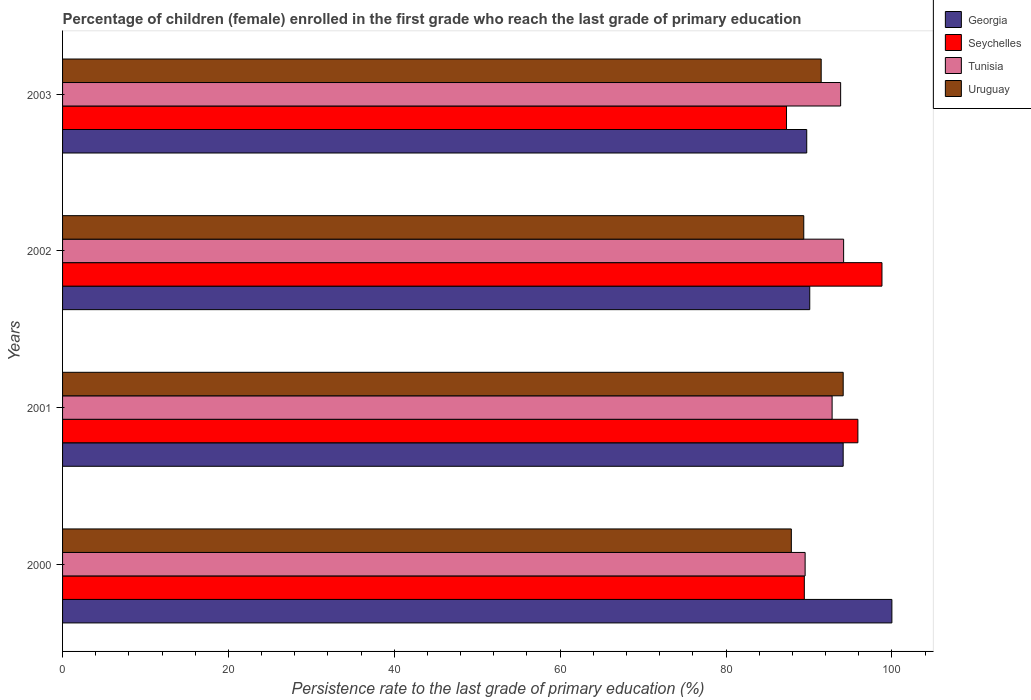Are the number of bars on each tick of the Y-axis equal?
Ensure brevity in your answer.  Yes. How many bars are there on the 3rd tick from the top?
Offer a terse response. 4. What is the persistence rate of children in Uruguay in 2003?
Your response must be concise. 91.48. Across all years, what is the minimum persistence rate of children in Seychelles?
Your answer should be very brief. 87.3. In which year was the persistence rate of children in Georgia maximum?
Provide a short and direct response. 2000. In which year was the persistence rate of children in Georgia minimum?
Your answer should be compact. 2003. What is the total persistence rate of children in Tunisia in the graph?
Your answer should be compact. 370.33. What is the difference between the persistence rate of children in Georgia in 2000 and that in 2001?
Provide a succinct answer. 5.87. What is the difference between the persistence rate of children in Georgia in 2003 and the persistence rate of children in Tunisia in 2002?
Provide a succinct answer. -4.45. What is the average persistence rate of children in Tunisia per year?
Your answer should be compact. 92.58. In the year 2003, what is the difference between the persistence rate of children in Seychelles and persistence rate of children in Georgia?
Ensure brevity in your answer.  -2.44. What is the ratio of the persistence rate of children in Tunisia in 2001 to that in 2003?
Your answer should be very brief. 0.99. Is the difference between the persistence rate of children in Seychelles in 2000 and 2001 greater than the difference between the persistence rate of children in Georgia in 2000 and 2001?
Your answer should be compact. No. What is the difference between the highest and the second highest persistence rate of children in Seychelles?
Keep it short and to the point. 2.9. What is the difference between the highest and the lowest persistence rate of children in Georgia?
Provide a short and direct response. 10.27. Is it the case that in every year, the sum of the persistence rate of children in Tunisia and persistence rate of children in Uruguay is greater than the sum of persistence rate of children in Georgia and persistence rate of children in Seychelles?
Make the answer very short. No. What does the 2nd bar from the top in 2003 represents?
Your response must be concise. Tunisia. What does the 1st bar from the bottom in 2001 represents?
Make the answer very short. Georgia. Is it the case that in every year, the sum of the persistence rate of children in Tunisia and persistence rate of children in Seychelles is greater than the persistence rate of children in Georgia?
Your response must be concise. Yes. Are all the bars in the graph horizontal?
Your answer should be very brief. Yes. How many years are there in the graph?
Your response must be concise. 4. Does the graph contain grids?
Offer a very short reply. No. Where does the legend appear in the graph?
Your response must be concise. Top right. What is the title of the graph?
Keep it short and to the point. Percentage of children (female) enrolled in the first grade who reach the last grade of primary education. Does "North America" appear as one of the legend labels in the graph?
Your answer should be compact. No. What is the label or title of the X-axis?
Offer a very short reply. Persistence rate to the last grade of primary education (%). What is the Persistence rate to the last grade of primary education (%) of Georgia in 2000?
Offer a terse response. 100. What is the Persistence rate to the last grade of primary education (%) of Seychelles in 2000?
Provide a succinct answer. 89.44. What is the Persistence rate to the last grade of primary education (%) in Tunisia in 2000?
Ensure brevity in your answer.  89.54. What is the Persistence rate to the last grade of primary education (%) of Uruguay in 2000?
Offer a very short reply. 87.88. What is the Persistence rate to the last grade of primary education (%) of Georgia in 2001?
Ensure brevity in your answer.  94.13. What is the Persistence rate to the last grade of primary education (%) of Seychelles in 2001?
Keep it short and to the point. 95.9. What is the Persistence rate to the last grade of primary education (%) of Tunisia in 2001?
Your answer should be compact. 92.79. What is the Persistence rate to the last grade of primary education (%) in Uruguay in 2001?
Provide a succinct answer. 94.13. What is the Persistence rate to the last grade of primary education (%) of Georgia in 2002?
Offer a terse response. 90.1. What is the Persistence rate to the last grade of primary education (%) of Seychelles in 2002?
Your answer should be very brief. 98.8. What is the Persistence rate to the last grade of primary education (%) in Tunisia in 2002?
Provide a succinct answer. 94.18. What is the Persistence rate to the last grade of primary education (%) of Uruguay in 2002?
Your answer should be compact. 89.37. What is the Persistence rate to the last grade of primary education (%) of Georgia in 2003?
Provide a succinct answer. 89.73. What is the Persistence rate to the last grade of primary education (%) of Seychelles in 2003?
Ensure brevity in your answer.  87.3. What is the Persistence rate to the last grade of primary education (%) of Tunisia in 2003?
Your answer should be very brief. 93.82. What is the Persistence rate to the last grade of primary education (%) in Uruguay in 2003?
Make the answer very short. 91.48. Across all years, what is the maximum Persistence rate to the last grade of primary education (%) in Georgia?
Make the answer very short. 100. Across all years, what is the maximum Persistence rate to the last grade of primary education (%) in Seychelles?
Make the answer very short. 98.8. Across all years, what is the maximum Persistence rate to the last grade of primary education (%) in Tunisia?
Ensure brevity in your answer.  94.18. Across all years, what is the maximum Persistence rate to the last grade of primary education (%) in Uruguay?
Your answer should be compact. 94.13. Across all years, what is the minimum Persistence rate to the last grade of primary education (%) in Georgia?
Your answer should be very brief. 89.73. Across all years, what is the minimum Persistence rate to the last grade of primary education (%) of Seychelles?
Make the answer very short. 87.3. Across all years, what is the minimum Persistence rate to the last grade of primary education (%) in Tunisia?
Offer a terse response. 89.54. Across all years, what is the minimum Persistence rate to the last grade of primary education (%) of Uruguay?
Ensure brevity in your answer.  87.88. What is the total Persistence rate to the last grade of primary education (%) in Georgia in the graph?
Provide a succinct answer. 373.95. What is the total Persistence rate to the last grade of primary education (%) in Seychelles in the graph?
Your answer should be compact. 371.44. What is the total Persistence rate to the last grade of primary education (%) in Tunisia in the graph?
Keep it short and to the point. 370.33. What is the total Persistence rate to the last grade of primary education (%) in Uruguay in the graph?
Your answer should be compact. 362.85. What is the difference between the Persistence rate to the last grade of primary education (%) of Georgia in 2000 and that in 2001?
Ensure brevity in your answer.  5.87. What is the difference between the Persistence rate to the last grade of primary education (%) in Seychelles in 2000 and that in 2001?
Give a very brief answer. -6.46. What is the difference between the Persistence rate to the last grade of primary education (%) of Tunisia in 2000 and that in 2001?
Provide a succinct answer. -3.25. What is the difference between the Persistence rate to the last grade of primary education (%) in Uruguay in 2000 and that in 2001?
Provide a succinct answer. -6.25. What is the difference between the Persistence rate to the last grade of primary education (%) in Georgia in 2000 and that in 2002?
Keep it short and to the point. 9.9. What is the difference between the Persistence rate to the last grade of primary education (%) of Seychelles in 2000 and that in 2002?
Offer a terse response. -9.36. What is the difference between the Persistence rate to the last grade of primary education (%) of Tunisia in 2000 and that in 2002?
Provide a succinct answer. -4.64. What is the difference between the Persistence rate to the last grade of primary education (%) of Uruguay in 2000 and that in 2002?
Make the answer very short. -1.5. What is the difference between the Persistence rate to the last grade of primary education (%) of Georgia in 2000 and that in 2003?
Offer a very short reply. 10.27. What is the difference between the Persistence rate to the last grade of primary education (%) in Seychelles in 2000 and that in 2003?
Your answer should be compact. 2.15. What is the difference between the Persistence rate to the last grade of primary education (%) in Tunisia in 2000 and that in 2003?
Keep it short and to the point. -4.28. What is the difference between the Persistence rate to the last grade of primary education (%) of Uruguay in 2000 and that in 2003?
Offer a very short reply. -3.6. What is the difference between the Persistence rate to the last grade of primary education (%) in Georgia in 2001 and that in 2002?
Offer a very short reply. 4.03. What is the difference between the Persistence rate to the last grade of primary education (%) of Seychelles in 2001 and that in 2002?
Provide a succinct answer. -2.9. What is the difference between the Persistence rate to the last grade of primary education (%) in Tunisia in 2001 and that in 2002?
Provide a succinct answer. -1.39. What is the difference between the Persistence rate to the last grade of primary education (%) of Uruguay in 2001 and that in 2002?
Give a very brief answer. 4.76. What is the difference between the Persistence rate to the last grade of primary education (%) in Georgia in 2001 and that in 2003?
Keep it short and to the point. 4.39. What is the difference between the Persistence rate to the last grade of primary education (%) in Seychelles in 2001 and that in 2003?
Keep it short and to the point. 8.61. What is the difference between the Persistence rate to the last grade of primary education (%) in Tunisia in 2001 and that in 2003?
Ensure brevity in your answer.  -1.03. What is the difference between the Persistence rate to the last grade of primary education (%) of Uruguay in 2001 and that in 2003?
Make the answer very short. 2.65. What is the difference between the Persistence rate to the last grade of primary education (%) in Georgia in 2002 and that in 2003?
Make the answer very short. 0.36. What is the difference between the Persistence rate to the last grade of primary education (%) of Seychelles in 2002 and that in 2003?
Your answer should be very brief. 11.51. What is the difference between the Persistence rate to the last grade of primary education (%) in Tunisia in 2002 and that in 2003?
Your answer should be compact. 0.36. What is the difference between the Persistence rate to the last grade of primary education (%) of Uruguay in 2002 and that in 2003?
Ensure brevity in your answer.  -2.1. What is the difference between the Persistence rate to the last grade of primary education (%) in Georgia in 2000 and the Persistence rate to the last grade of primary education (%) in Seychelles in 2001?
Keep it short and to the point. 4.1. What is the difference between the Persistence rate to the last grade of primary education (%) in Georgia in 2000 and the Persistence rate to the last grade of primary education (%) in Tunisia in 2001?
Your answer should be compact. 7.21. What is the difference between the Persistence rate to the last grade of primary education (%) of Georgia in 2000 and the Persistence rate to the last grade of primary education (%) of Uruguay in 2001?
Provide a short and direct response. 5.87. What is the difference between the Persistence rate to the last grade of primary education (%) of Seychelles in 2000 and the Persistence rate to the last grade of primary education (%) of Tunisia in 2001?
Provide a short and direct response. -3.35. What is the difference between the Persistence rate to the last grade of primary education (%) of Seychelles in 2000 and the Persistence rate to the last grade of primary education (%) of Uruguay in 2001?
Your answer should be compact. -4.69. What is the difference between the Persistence rate to the last grade of primary education (%) in Tunisia in 2000 and the Persistence rate to the last grade of primary education (%) in Uruguay in 2001?
Give a very brief answer. -4.59. What is the difference between the Persistence rate to the last grade of primary education (%) of Georgia in 2000 and the Persistence rate to the last grade of primary education (%) of Seychelles in 2002?
Offer a terse response. 1.2. What is the difference between the Persistence rate to the last grade of primary education (%) in Georgia in 2000 and the Persistence rate to the last grade of primary education (%) in Tunisia in 2002?
Your answer should be compact. 5.82. What is the difference between the Persistence rate to the last grade of primary education (%) of Georgia in 2000 and the Persistence rate to the last grade of primary education (%) of Uruguay in 2002?
Your response must be concise. 10.63. What is the difference between the Persistence rate to the last grade of primary education (%) of Seychelles in 2000 and the Persistence rate to the last grade of primary education (%) of Tunisia in 2002?
Offer a very short reply. -4.74. What is the difference between the Persistence rate to the last grade of primary education (%) of Seychelles in 2000 and the Persistence rate to the last grade of primary education (%) of Uruguay in 2002?
Your answer should be compact. 0.07. What is the difference between the Persistence rate to the last grade of primary education (%) in Tunisia in 2000 and the Persistence rate to the last grade of primary education (%) in Uruguay in 2002?
Your response must be concise. 0.17. What is the difference between the Persistence rate to the last grade of primary education (%) of Georgia in 2000 and the Persistence rate to the last grade of primary education (%) of Seychelles in 2003?
Offer a terse response. 12.71. What is the difference between the Persistence rate to the last grade of primary education (%) of Georgia in 2000 and the Persistence rate to the last grade of primary education (%) of Tunisia in 2003?
Make the answer very short. 6.18. What is the difference between the Persistence rate to the last grade of primary education (%) in Georgia in 2000 and the Persistence rate to the last grade of primary education (%) in Uruguay in 2003?
Your answer should be very brief. 8.52. What is the difference between the Persistence rate to the last grade of primary education (%) of Seychelles in 2000 and the Persistence rate to the last grade of primary education (%) of Tunisia in 2003?
Make the answer very short. -4.38. What is the difference between the Persistence rate to the last grade of primary education (%) in Seychelles in 2000 and the Persistence rate to the last grade of primary education (%) in Uruguay in 2003?
Make the answer very short. -2.03. What is the difference between the Persistence rate to the last grade of primary education (%) in Tunisia in 2000 and the Persistence rate to the last grade of primary education (%) in Uruguay in 2003?
Provide a short and direct response. -1.94. What is the difference between the Persistence rate to the last grade of primary education (%) in Georgia in 2001 and the Persistence rate to the last grade of primary education (%) in Seychelles in 2002?
Give a very brief answer. -4.68. What is the difference between the Persistence rate to the last grade of primary education (%) in Georgia in 2001 and the Persistence rate to the last grade of primary education (%) in Tunisia in 2002?
Your response must be concise. -0.05. What is the difference between the Persistence rate to the last grade of primary education (%) of Georgia in 2001 and the Persistence rate to the last grade of primary education (%) of Uruguay in 2002?
Give a very brief answer. 4.75. What is the difference between the Persistence rate to the last grade of primary education (%) in Seychelles in 2001 and the Persistence rate to the last grade of primary education (%) in Tunisia in 2002?
Your answer should be very brief. 1.72. What is the difference between the Persistence rate to the last grade of primary education (%) in Seychelles in 2001 and the Persistence rate to the last grade of primary education (%) in Uruguay in 2002?
Provide a short and direct response. 6.53. What is the difference between the Persistence rate to the last grade of primary education (%) of Tunisia in 2001 and the Persistence rate to the last grade of primary education (%) of Uruguay in 2002?
Offer a terse response. 3.42. What is the difference between the Persistence rate to the last grade of primary education (%) in Georgia in 2001 and the Persistence rate to the last grade of primary education (%) in Seychelles in 2003?
Keep it short and to the point. 6.83. What is the difference between the Persistence rate to the last grade of primary education (%) in Georgia in 2001 and the Persistence rate to the last grade of primary education (%) in Tunisia in 2003?
Provide a short and direct response. 0.31. What is the difference between the Persistence rate to the last grade of primary education (%) in Georgia in 2001 and the Persistence rate to the last grade of primary education (%) in Uruguay in 2003?
Make the answer very short. 2.65. What is the difference between the Persistence rate to the last grade of primary education (%) of Seychelles in 2001 and the Persistence rate to the last grade of primary education (%) of Tunisia in 2003?
Offer a very short reply. 2.08. What is the difference between the Persistence rate to the last grade of primary education (%) in Seychelles in 2001 and the Persistence rate to the last grade of primary education (%) in Uruguay in 2003?
Ensure brevity in your answer.  4.43. What is the difference between the Persistence rate to the last grade of primary education (%) in Tunisia in 2001 and the Persistence rate to the last grade of primary education (%) in Uruguay in 2003?
Provide a succinct answer. 1.32. What is the difference between the Persistence rate to the last grade of primary education (%) in Georgia in 2002 and the Persistence rate to the last grade of primary education (%) in Seychelles in 2003?
Offer a very short reply. 2.8. What is the difference between the Persistence rate to the last grade of primary education (%) in Georgia in 2002 and the Persistence rate to the last grade of primary education (%) in Tunisia in 2003?
Provide a succinct answer. -3.72. What is the difference between the Persistence rate to the last grade of primary education (%) of Georgia in 2002 and the Persistence rate to the last grade of primary education (%) of Uruguay in 2003?
Your answer should be very brief. -1.38. What is the difference between the Persistence rate to the last grade of primary education (%) of Seychelles in 2002 and the Persistence rate to the last grade of primary education (%) of Tunisia in 2003?
Provide a short and direct response. 4.98. What is the difference between the Persistence rate to the last grade of primary education (%) in Seychelles in 2002 and the Persistence rate to the last grade of primary education (%) in Uruguay in 2003?
Provide a short and direct response. 7.33. What is the difference between the Persistence rate to the last grade of primary education (%) of Tunisia in 2002 and the Persistence rate to the last grade of primary education (%) of Uruguay in 2003?
Your answer should be compact. 2.71. What is the average Persistence rate to the last grade of primary education (%) in Georgia per year?
Ensure brevity in your answer.  93.49. What is the average Persistence rate to the last grade of primary education (%) of Seychelles per year?
Provide a succinct answer. 92.86. What is the average Persistence rate to the last grade of primary education (%) in Tunisia per year?
Your answer should be compact. 92.58. What is the average Persistence rate to the last grade of primary education (%) of Uruguay per year?
Provide a succinct answer. 90.71. In the year 2000, what is the difference between the Persistence rate to the last grade of primary education (%) in Georgia and Persistence rate to the last grade of primary education (%) in Seychelles?
Your answer should be compact. 10.56. In the year 2000, what is the difference between the Persistence rate to the last grade of primary education (%) in Georgia and Persistence rate to the last grade of primary education (%) in Tunisia?
Make the answer very short. 10.46. In the year 2000, what is the difference between the Persistence rate to the last grade of primary education (%) in Georgia and Persistence rate to the last grade of primary education (%) in Uruguay?
Offer a very short reply. 12.12. In the year 2000, what is the difference between the Persistence rate to the last grade of primary education (%) of Seychelles and Persistence rate to the last grade of primary education (%) of Tunisia?
Provide a succinct answer. -0.1. In the year 2000, what is the difference between the Persistence rate to the last grade of primary education (%) of Seychelles and Persistence rate to the last grade of primary education (%) of Uruguay?
Offer a very short reply. 1.57. In the year 2000, what is the difference between the Persistence rate to the last grade of primary education (%) in Tunisia and Persistence rate to the last grade of primary education (%) in Uruguay?
Offer a very short reply. 1.66. In the year 2001, what is the difference between the Persistence rate to the last grade of primary education (%) of Georgia and Persistence rate to the last grade of primary education (%) of Seychelles?
Provide a short and direct response. -1.77. In the year 2001, what is the difference between the Persistence rate to the last grade of primary education (%) in Georgia and Persistence rate to the last grade of primary education (%) in Tunisia?
Provide a succinct answer. 1.33. In the year 2001, what is the difference between the Persistence rate to the last grade of primary education (%) in Georgia and Persistence rate to the last grade of primary education (%) in Uruguay?
Offer a terse response. -0. In the year 2001, what is the difference between the Persistence rate to the last grade of primary education (%) in Seychelles and Persistence rate to the last grade of primary education (%) in Tunisia?
Provide a succinct answer. 3.11. In the year 2001, what is the difference between the Persistence rate to the last grade of primary education (%) in Seychelles and Persistence rate to the last grade of primary education (%) in Uruguay?
Offer a very short reply. 1.77. In the year 2001, what is the difference between the Persistence rate to the last grade of primary education (%) in Tunisia and Persistence rate to the last grade of primary education (%) in Uruguay?
Keep it short and to the point. -1.34. In the year 2002, what is the difference between the Persistence rate to the last grade of primary education (%) of Georgia and Persistence rate to the last grade of primary education (%) of Seychelles?
Your answer should be very brief. -8.71. In the year 2002, what is the difference between the Persistence rate to the last grade of primary education (%) in Georgia and Persistence rate to the last grade of primary education (%) in Tunisia?
Keep it short and to the point. -4.08. In the year 2002, what is the difference between the Persistence rate to the last grade of primary education (%) in Georgia and Persistence rate to the last grade of primary education (%) in Uruguay?
Offer a very short reply. 0.72. In the year 2002, what is the difference between the Persistence rate to the last grade of primary education (%) in Seychelles and Persistence rate to the last grade of primary education (%) in Tunisia?
Provide a short and direct response. 4.62. In the year 2002, what is the difference between the Persistence rate to the last grade of primary education (%) in Seychelles and Persistence rate to the last grade of primary education (%) in Uruguay?
Give a very brief answer. 9.43. In the year 2002, what is the difference between the Persistence rate to the last grade of primary education (%) of Tunisia and Persistence rate to the last grade of primary education (%) of Uruguay?
Make the answer very short. 4.81. In the year 2003, what is the difference between the Persistence rate to the last grade of primary education (%) in Georgia and Persistence rate to the last grade of primary education (%) in Seychelles?
Provide a short and direct response. 2.44. In the year 2003, what is the difference between the Persistence rate to the last grade of primary education (%) of Georgia and Persistence rate to the last grade of primary education (%) of Tunisia?
Offer a very short reply. -4.09. In the year 2003, what is the difference between the Persistence rate to the last grade of primary education (%) of Georgia and Persistence rate to the last grade of primary education (%) of Uruguay?
Ensure brevity in your answer.  -1.74. In the year 2003, what is the difference between the Persistence rate to the last grade of primary education (%) of Seychelles and Persistence rate to the last grade of primary education (%) of Tunisia?
Give a very brief answer. -6.53. In the year 2003, what is the difference between the Persistence rate to the last grade of primary education (%) of Seychelles and Persistence rate to the last grade of primary education (%) of Uruguay?
Your answer should be very brief. -4.18. In the year 2003, what is the difference between the Persistence rate to the last grade of primary education (%) in Tunisia and Persistence rate to the last grade of primary education (%) in Uruguay?
Your answer should be very brief. 2.35. What is the ratio of the Persistence rate to the last grade of primary education (%) in Georgia in 2000 to that in 2001?
Provide a short and direct response. 1.06. What is the ratio of the Persistence rate to the last grade of primary education (%) in Seychelles in 2000 to that in 2001?
Your response must be concise. 0.93. What is the ratio of the Persistence rate to the last grade of primary education (%) of Tunisia in 2000 to that in 2001?
Keep it short and to the point. 0.96. What is the ratio of the Persistence rate to the last grade of primary education (%) of Uruguay in 2000 to that in 2001?
Ensure brevity in your answer.  0.93. What is the ratio of the Persistence rate to the last grade of primary education (%) in Georgia in 2000 to that in 2002?
Your response must be concise. 1.11. What is the ratio of the Persistence rate to the last grade of primary education (%) in Seychelles in 2000 to that in 2002?
Offer a very short reply. 0.91. What is the ratio of the Persistence rate to the last grade of primary education (%) of Tunisia in 2000 to that in 2002?
Offer a terse response. 0.95. What is the ratio of the Persistence rate to the last grade of primary education (%) of Uruguay in 2000 to that in 2002?
Your answer should be compact. 0.98. What is the ratio of the Persistence rate to the last grade of primary education (%) in Georgia in 2000 to that in 2003?
Your answer should be very brief. 1.11. What is the ratio of the Persistence rate to the last grade of primary education (%) in Seychelles in 2000 to that in 2003?
Your answer should be compact. 1.02. What is the ratio of the Persistence rate to the last grade of primary education (%) in Tunisia in 2000 to that in 2003?
Make the answer very short. 0.95. What is the ratio of the Persistence rate to the last grade of primary education (%) of Uruguay in 2000 to that in 2003?
Offer a very short reply. 0.96. What is the ratio of the Persistence rate to the last grade of primary education (%) in Georgia in 2001 to that in 2002?
Your response must be concise. 1.04. What is the ratio of the Persistence rate to the last grade of primary education (%) in Seychelles in 2001 to that in 2002?
Your answer should be compact. 0.97. What is the ratio of the Persistence rate to the last grade of primary education (%) in Uruguay in 2001 to that in 2002?
Offer a terse response. 1.05. What is the ratio of the Persistence rate to the last grade of primary education (%) in Georgia in 2001 to that in 2003?
Offer a very short reply. 1.05. What is the ratio of the Persistence rate to the last grade of primary education (%) in Seychelles in 2001 to that in 2003?
Provide a short and direct response. 1.1. What is the ratio of the Persistence rate to the last grade of primary education (%) of Uruguay in 2001 to that in 2003?
Give a very brief answer. 1.03. What is the ratio of the Persistence rate to the last grade of primary education (%) in Seychelles in 2002 to that in 2003?
Your answer should be very brief. 1.13. What is the ratio of the Persistence rate to the last grade of primary education (%) in Uruguay in 2002 to that in 2003?
Give a very brief answer. 0.98. What is the difference between the highest and the second highest Persistence rate to the last grade of primary education (%) in Georgia?
Offer a terse response. 5.87. What is the difference between the highest and the second highest Persistence rate to the last grade of primary education (%) of Seychelles?
Make the answer very short. 2.9. What is the difference between the highest and the second highest Persistence rate to the last grade of primary education (%) in Tunisia?
Give a very brief answer. 0.36. What is the difference between the highest and the second highest Persistence rate to the last grade of primary education (%) in Uruguay?
Provide a succinct answer. 2.65. What is the difference between the highest and the lowest Persistence rate to the last grade of primary education (%) in Georgia?
Your answer should be compact. 10.27. What is the difference between the highest and the lowest Persistence rate to the last grade of primary education (%) in Seychelles?
Ensure brevity in your answer.  11.51. What is the difference between the highest and the lowest Persistence rate to the last grade of primary education (%) of Tunisia?
Keep it short and to the point. 4.64. What is the difference between the highest and the lowest Persistence rate to the last grade of primary education (%) of Uruguay?
Offer a terse response. 6.25. 